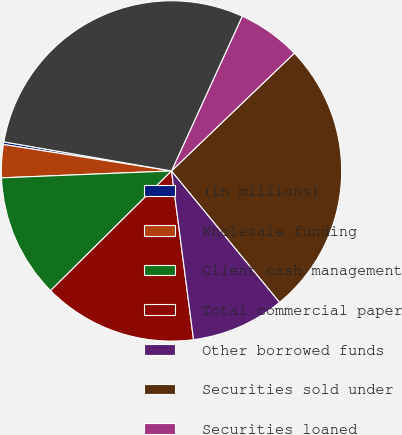<chart> <loc_0><loc_0><loc_500><loc_500><pie_chart><fcel>(in millions)<fcel>Wholesale funding<fcel>Client cash management<fcel>Total commercial paper<fcel>Other borrowed funds<fcel>Securities sold under<fcel>Securities loaned<fcel>Total securities loaned or<nl><fcel>0.25%<fcel>3.13%<fcel>11.77%<fcel>14.65%<fcel>8.89%<fcel>26.21%<fcel>6.01%<fcel>29.09%<nl></chart> 